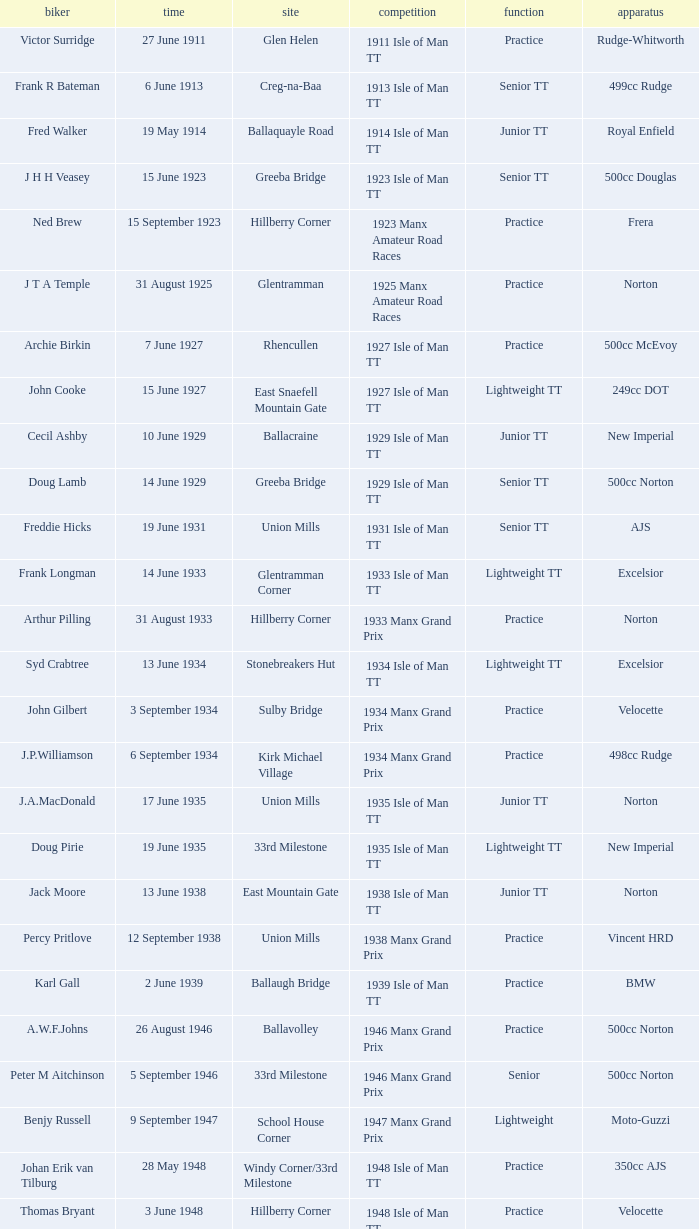What machine did Kenneth E. Herbert ride? 499cc Norton. 